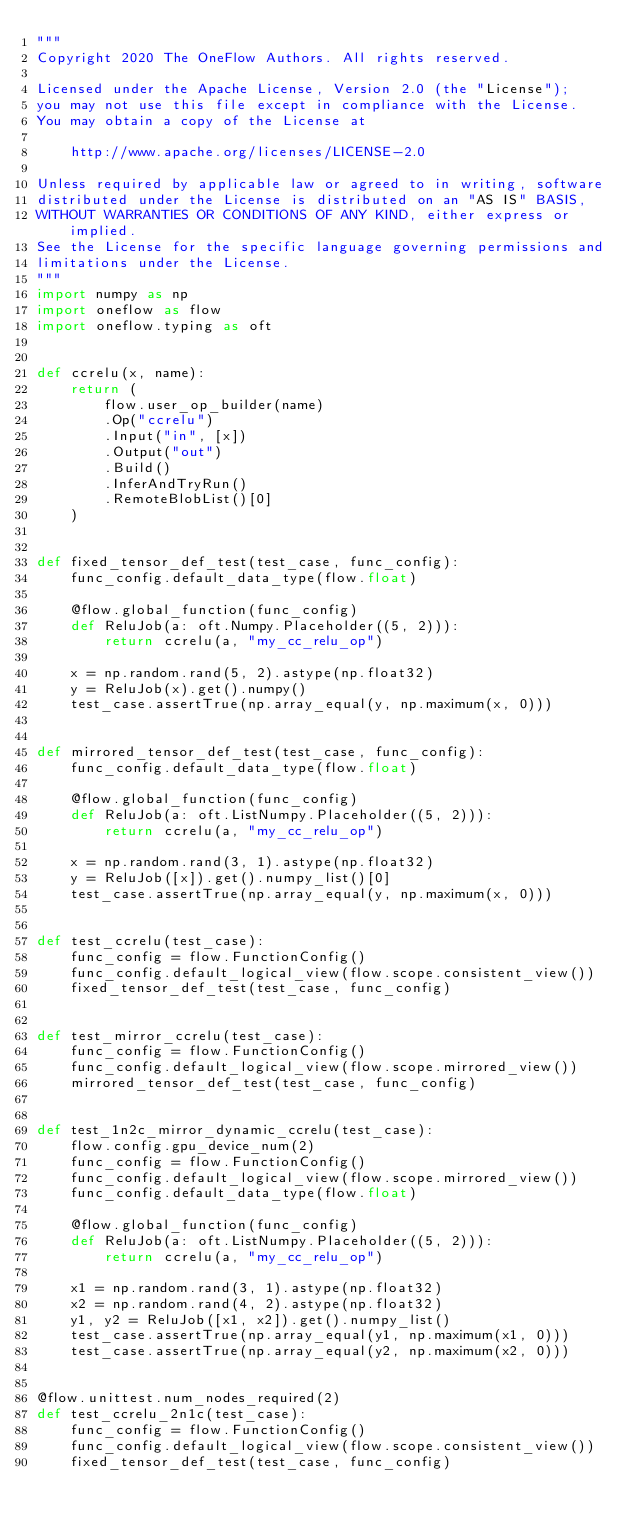Convert code to text. <code><loc_0><loc_0><loc_500><loc_500><_Python_>"""
Copyright 2020 The OneFlow Authors. All rights reserved.

Licensed under the Apache License, Version 2.0 (the "License");
you may not use this file except in compliance with the License.
You may obtain a copy of the License at

    http://www.apache.org/licenses/LICENSE-2.0

Unless required by applicable law or agreed to in writing, software
distributed under the License is distributed on an "AS IS" BASIS,
WITHOUT WARRANTIES OR CONDITIONS OF ANY KIND, either express or implied.
See the License for the specific language governing permissions and
limitations under the License.
"""
import numpy as np
import oneflow as flow
import oneflow.typing as oft


def ccrelu(x, name):
    return (
        flow.user_op_builder(name)
        .Op("ccrelu")
        .Input("in", [x])
        .Output("out")
        .Build()
        .InferAndTryRun()
        .RemoteBlobList()[0]
    )


def fixed_tensor_def_test(test_case, func_config):
    func_config.default_data_type(flow.float)

    @flow.global_function(func_config)
    def ReluJob(a: oft.Numpy.Placeholder((5, 2))):
        return ccrelu(a, "my_cc_relu_op")

    x = np.random.rand(5, 2).astype(np.float32)
    y = ReluJob(x).get().numpy()
    test_case.assertTrue(np.array_equal(y, np.maximum(x, 0)))


def mirrored_tensor_def_test(test_case, func_config):
    func_config.default_data_type(flow.float)

    @flow.global_function(func_config)
    def ReluJob(a: oft.ListNumpy.Placeholder((5, 2))):
        return ccrelu(a, "my_cc_relu_op")

    x = np.random.rand(3, 1).astype(np.float32)
    y = ReluJob([x]).get().numpy_list()[0]
    test_case.assertTrue(np.array_equal(y, np.maximum(x, 0)))


def test_ccrelu(test_case):
    func_config = flow.FunctionConfig()
    func_config.default_logical_view(flow.scope.consistent_view())
    fixed_tensor_def_test(test_case, func_config)


def test_mirror_ccrelu(test_case):
    func_config = flow.FunctionConfig()
    func_config.default_logical_view(flow.scope.mirrored_view())
    mirrored_tensor_def_test(test_case, func_config)


def test_1n2c_mirror_dynamic_ccrelu(test_case):
    flow.config.gpu_device_num(2)
    func_config = flow.FunctionConfig()
    func_config.default_logical_view(flow.scope.mirrored_view())
    func_config.default_data_type(flow.float)

    @flow.global_function(func_config)
    def ReluJob(a: oft.ListNumpy.Placeholder((5, 2))):
        return ccrelu(a, "my_cc_relu_op")

    x1 = np.random.rand(3, 1).astype(np.float32)
    x2 = np.random.rand(4, 2).astype(np.float32)
    y1, y2 = ReluJob([x1, x2]).get().numpy_list()
    test_case.assertTrue(np.array_equal(y1, np.maximum(x1, 0)))
    test_case.assertTrue(np.array_equal(y2, np.maximum(x2, 0)))


@flow.unittest.num_nodes_required(2)
def test_ccrelu_2n1c(test_case):
    func_config = flow.FunctionConfig()
    func_config.default_logical_view(flow.scope.consistent_view())
    fixed_tensor_def_test(test_case, func_config)
</code> 